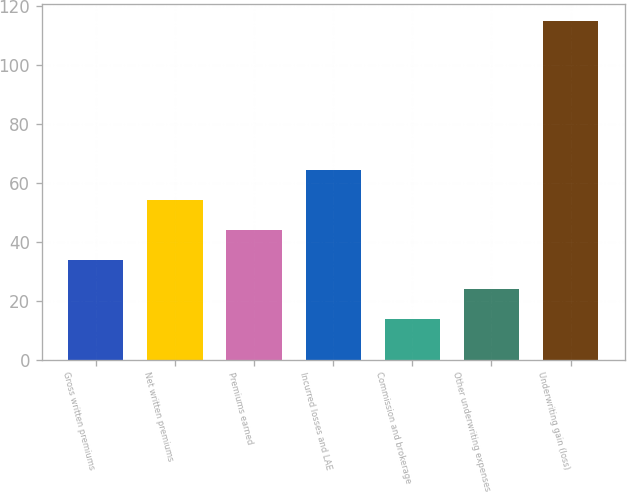Convert chart to OTSL. <chart><loc_0><loc_0><loc_500><loc_500><bar_chart><fcel>Gross written premiums<fcel>Net written premiums<fcel>Premiums earned<fcel>Incurred losses and LAE<fcel>Commission and brokerage<fcel>Other underwriting expenses<fcel>Underwriting gain (loss)<nl><fcel>33.92<fcel>54.14<fcel>44.03<fcel>64.25<fcel>13.7<fcel>23.81<fcel>114.8<nl></chart> 